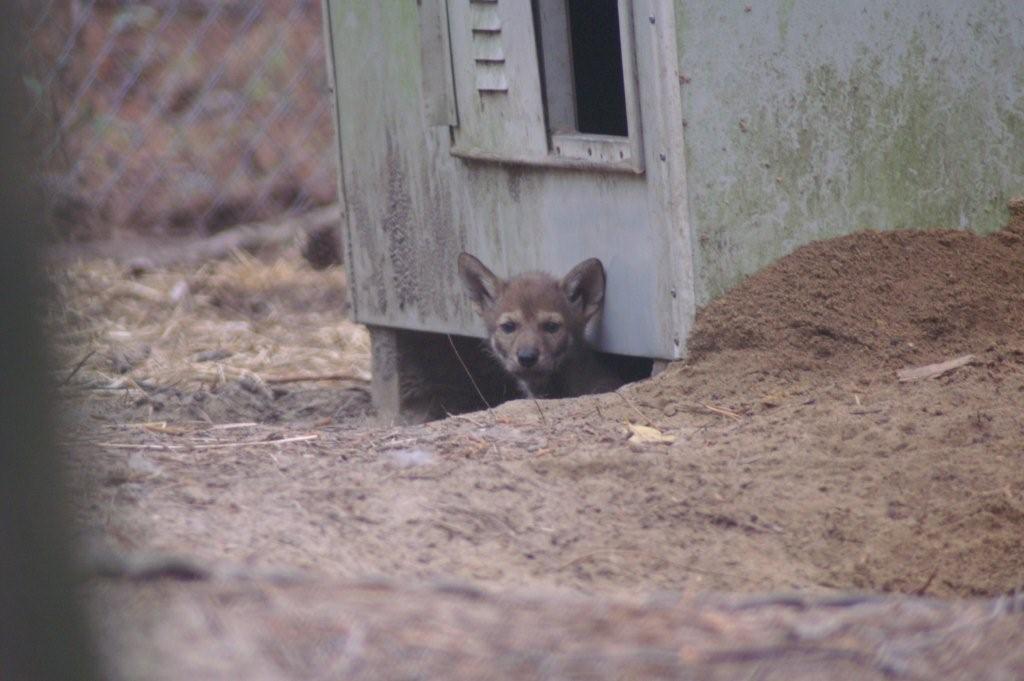Can you describe this image briefly? In this picture there is a fox under the room. At the top there is a window. On the left we can see the fencing. 